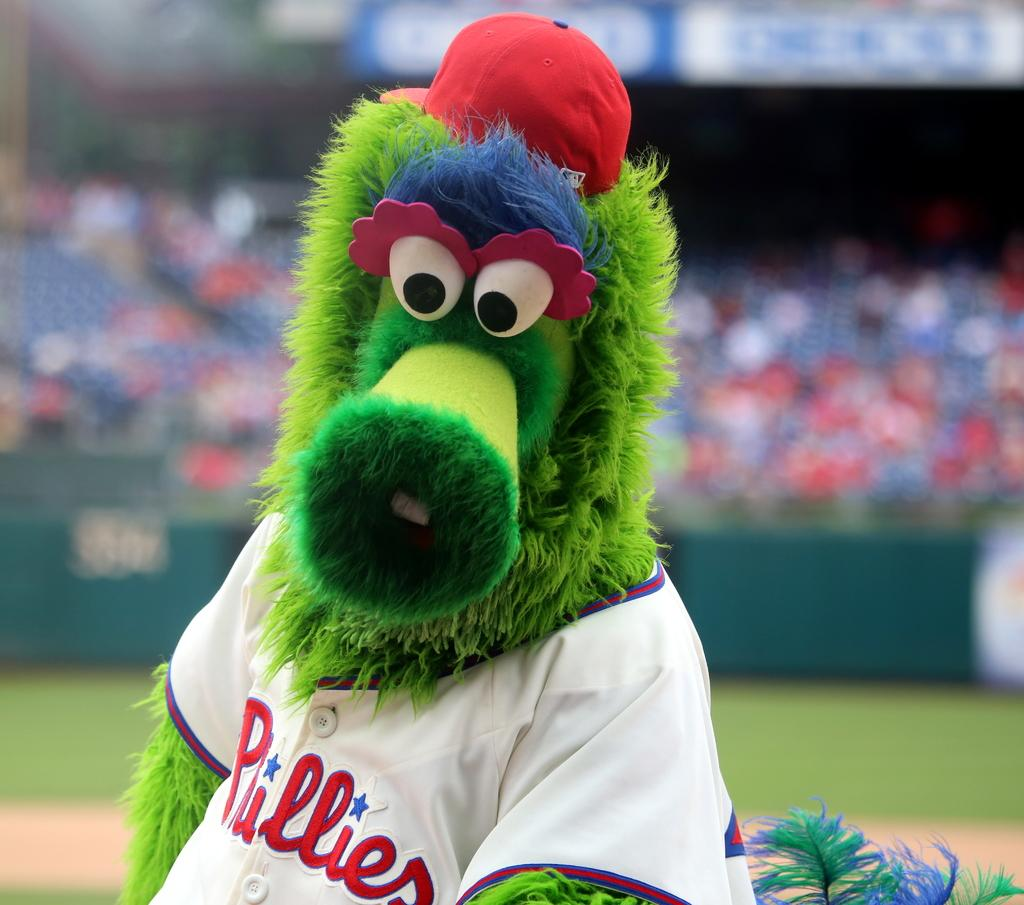<image>
Offer a succinct explanation of the picture presented. A green monster mascot is wearing a Phillies shirt 